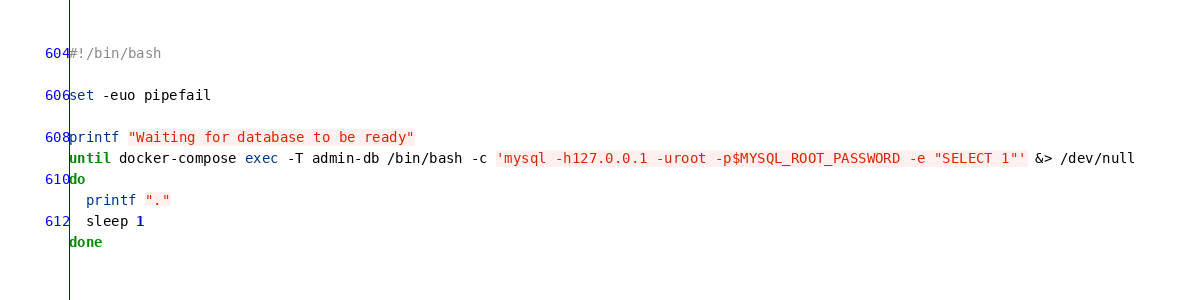Convert code to text. <code><loc_0><loc_0><loc_500><loc_500><_Bash_>#!/bin/bash

set -euo pipefail

printf "Waiting for database to be ready"
until docker-compose exec -T admin-db /bin/bash -c 'mysql -h127.0.0.1 -uroot -p$MYSQL_ROOT_PASSWORD -e "SELECT 1"' &> /dev/null
do
  printf "."
  sleep 1
done
</code> 